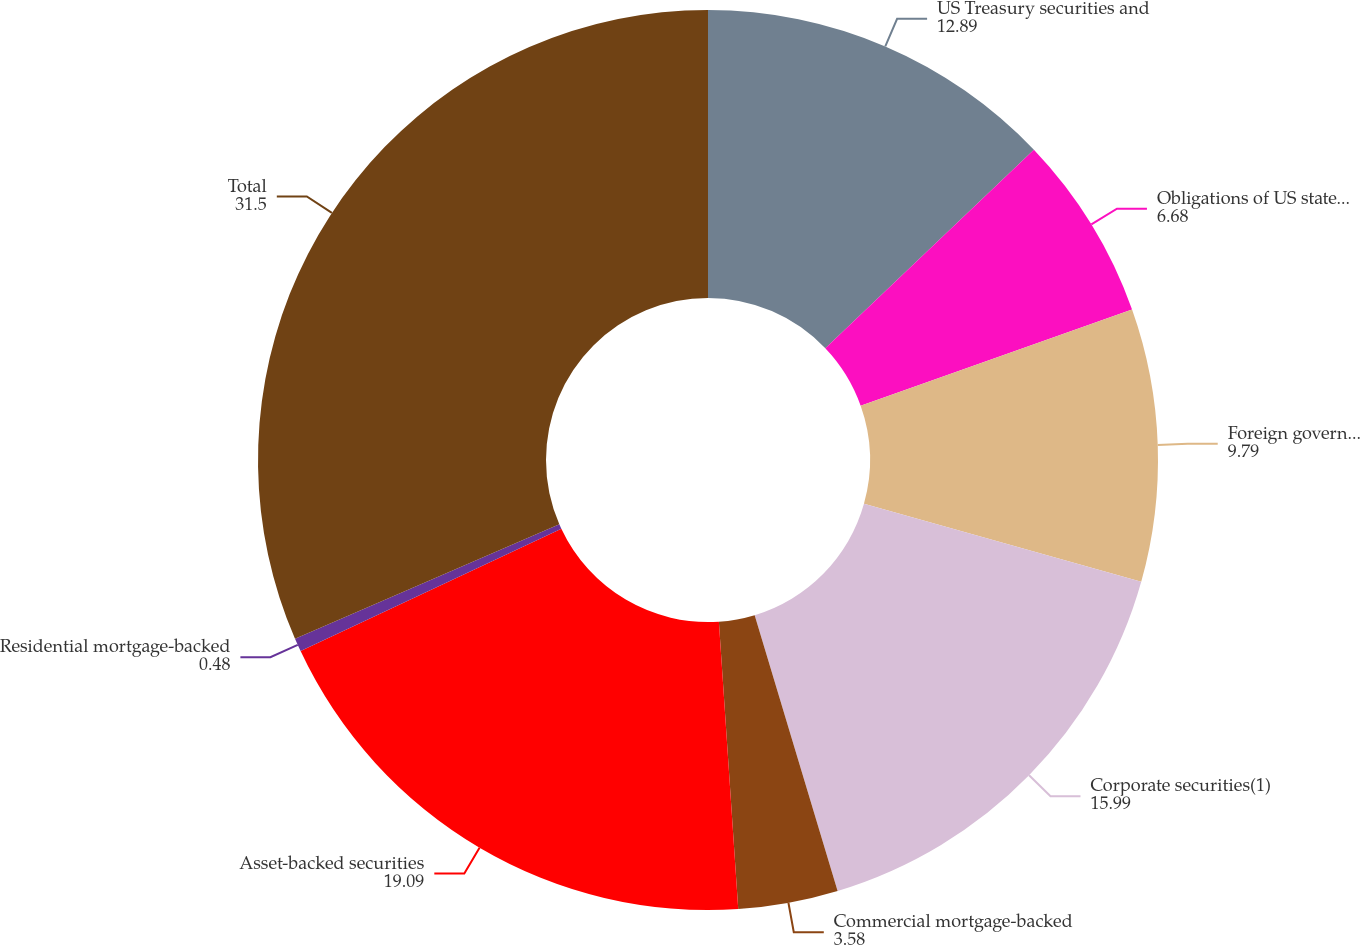Convert chart to OTSL. <chart><loc_0><loc_0><loc_500><loc_500><pie_chart><fcel>US Treasury securities and<fcel>Obligations of US states and<fcel>Foreign government bonds(1)<fcel>Corporate securities(1)<fcel>Commercial mortgage-backed<fcel>Asset-backed securities<fcel>Residential mortgage-backed<fcel>Total<nl><fcel>12.89%<fcel>6.68%<fcel>9.79%<fcel>15.99%<fcel>3.58%<fcel>19.09%<fcel>0.48%<fcel>31.5%<nl></chart> 